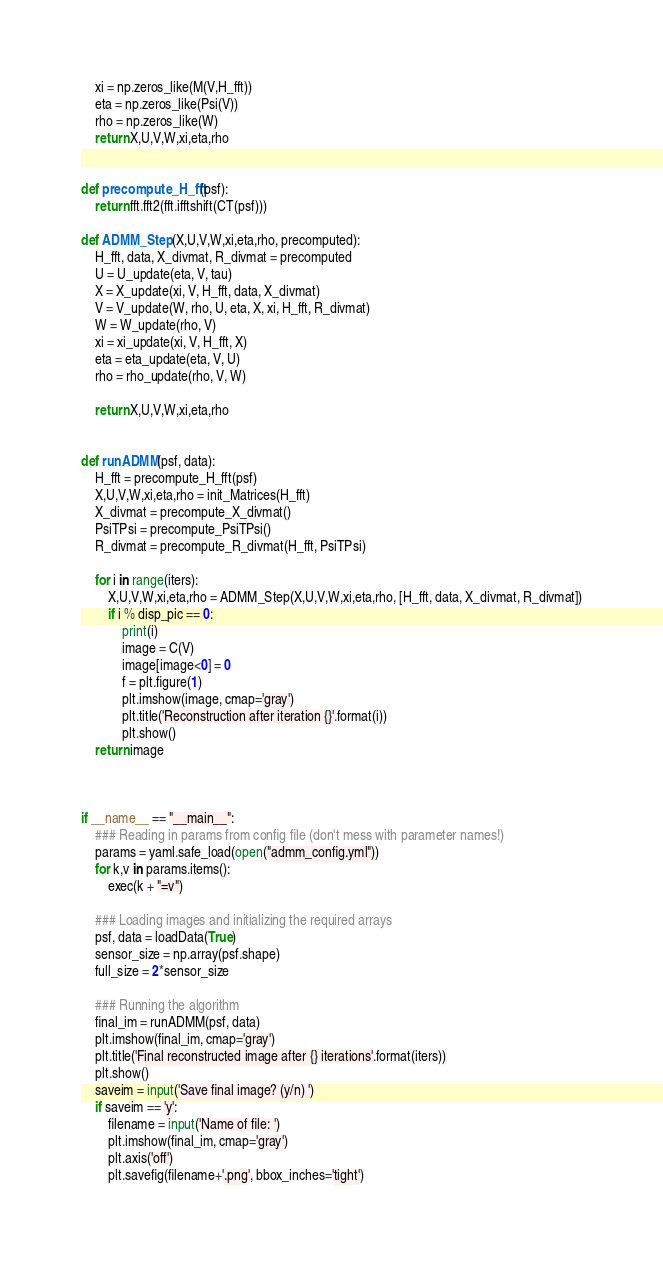<code> <loc_0><loc_0><loc_500><loc_500><_Python_>
    xi = np.zeros_like(M(V,H_fft))
    eta = np.zeros_like(Psi(V))
    rho = np.zeros_like(W)
    return X,U,V,W,xi,eta,rho


def precompute_H_fft(psf):
    return fft.fft2(fft.ifftshift(CT(psf)))

def ADMM_Step(X,U,V,W,xi,eta,rho, precomputed):
    H_fft, data, X_divmat, R_divmat = precomputed
    U = U_update(eta, V, tau)
    X = X_update(xi, V, H_fft, data, X_divmat)
    V = V_update(W, rho, U, eta, X, xi, H_fft, R_divmat)
    W = W_update(rho, V)
    xi = xi_update(xi, V, H_fft, X)
    eta = eta_update(eta, V, U)
    rho = rho_update(rho, V, W)
    
    return X,U,V,W,xi,eta,rho


def runADMM(psf, data):
    H_fft = precompute_H_fft(psf)
    X,U,V,W,xi,eta,rho = init_Matrices(H_fft)
    X_divmat = precompute_X_divmat()
    PsiTPsi = precompute_PsiTPsi()
    R_divmat = precompute_R_divmat(H_fft, PsiTPsi)
    
    for i in range(iters):
        X,U,V,W,xi,eta,rho = ADMM_Step(X,U,V,W,xi,eta,rho, [H_fft, data, X_divmat, R_divmat])
        if i % disp_pic == 0:
            print(i)
            image = C(V)
            image[image<0] = 0
            f = plt.figure(1)
            plt.imshow(image, cmap='gray')
            plt.title('Reconstruction after iteration {}'.format(i))
            plt.show()
    return image



if __name__ == "__main__":
    ### Reading in params from config file (don't mess with parameter names!)
    params = yaml.safe_load(open("admm_config.yml"))
    for k,v in params.items():
        exec(k + "=v")

    ### Loading images and initializing the required arrays
    psf, data = loadData(True)
    sensor_size = np.array(psf.shape)
    full_size = 2*sensor_size

    ### Running the algorithm
    final_im = runADMM(psf, data)
    plt.imshow(final_im, cmap='gray')
    plt.title('Final reconstructed image after {} iterations'.format(iters))
    plt.show()
    saveim = input('Save final image? (y/n) ')
    if saveim == 'y':
        filename = input('Name of file: ')
        plt.imshow(final_im, cmap='gray')
        plt.axis('off')
        plt.savefig(filename+'.png', bbox_inches='tight')

</code> 